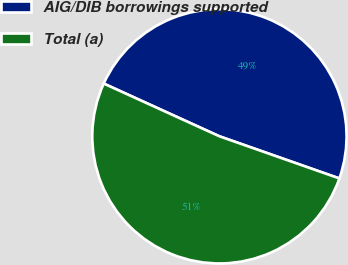Convert chart to OTSL. <chart><loc_0><loc_0><loc_500><loc_500><pie_chart><fcel>AIG/DIB borrowings supported<fcel>Total (a)<nl><fcel>48.57%<fcel>51.43%<nl></chart> 